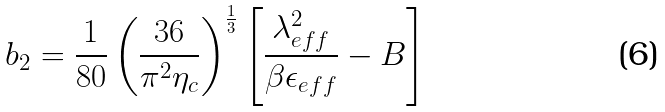Convert formula to latex. <formula><loc_0><loc_0><loc_500><loc_500>b _ { 2 } = \frac { 1 } { 8 0 } \left ( \frac { 3 6 } { \pi ^ { 2 } \eta _ { c } } \right ) ^ { \frac { 1 } { 3 } } \left [ \frac { \lambda _ { e f f } ^ { 2 } } { \beta \epsilon _ { e f f } } - B \right ]</formula> 